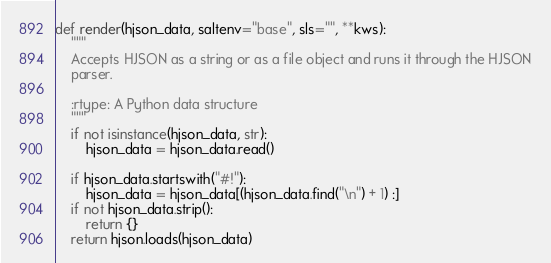Convert code to text. <code><loc_0><loc_0><loc_500><loc_500><_Python_>def render(hjson_data, saltenv="base", sls="", **kws):
    """
    Accepts HJSON as a string or as a file object and runs it through the HJSON
    parser.

    :rtype: A Python data structure
    """
    if not isinstance(hjson_data, str):
        hjson_data = hjson_data.read()

    if hjson_data.startswith("#!"):
        hjson_data = hjson_data[(hjson_data.find("\n") + 1) :]
    if not hjson_data.strip():
        return {}
    return hjson.loads(hjson_data)
</code> 